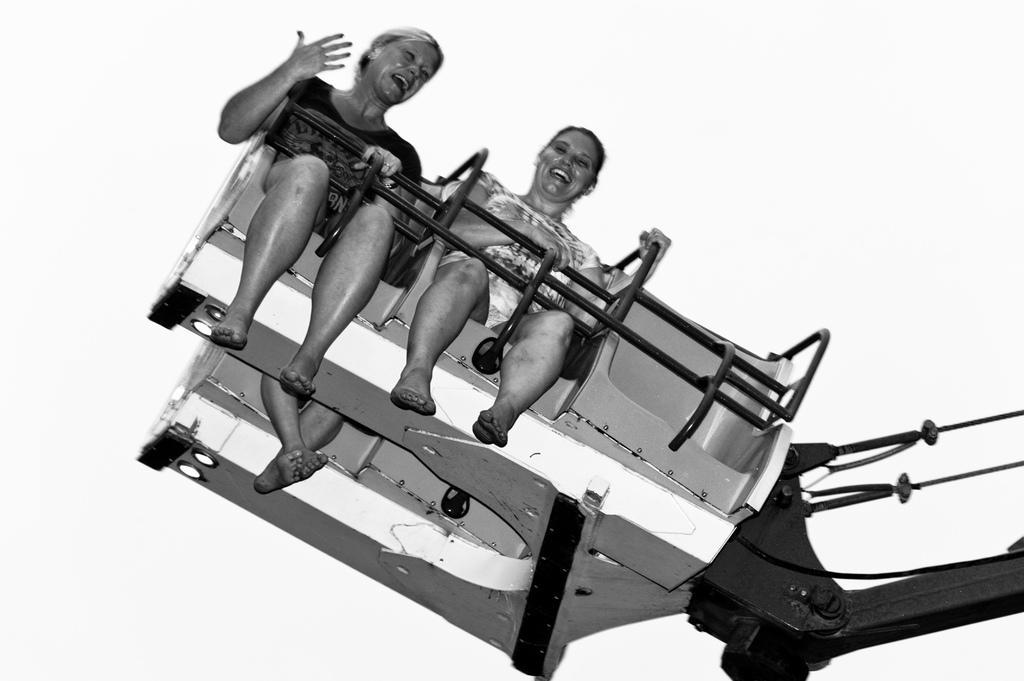Can you describe this image briefly? This is a black and white image. In the center of the image we can see women on a ride. In the background there is a sky. 